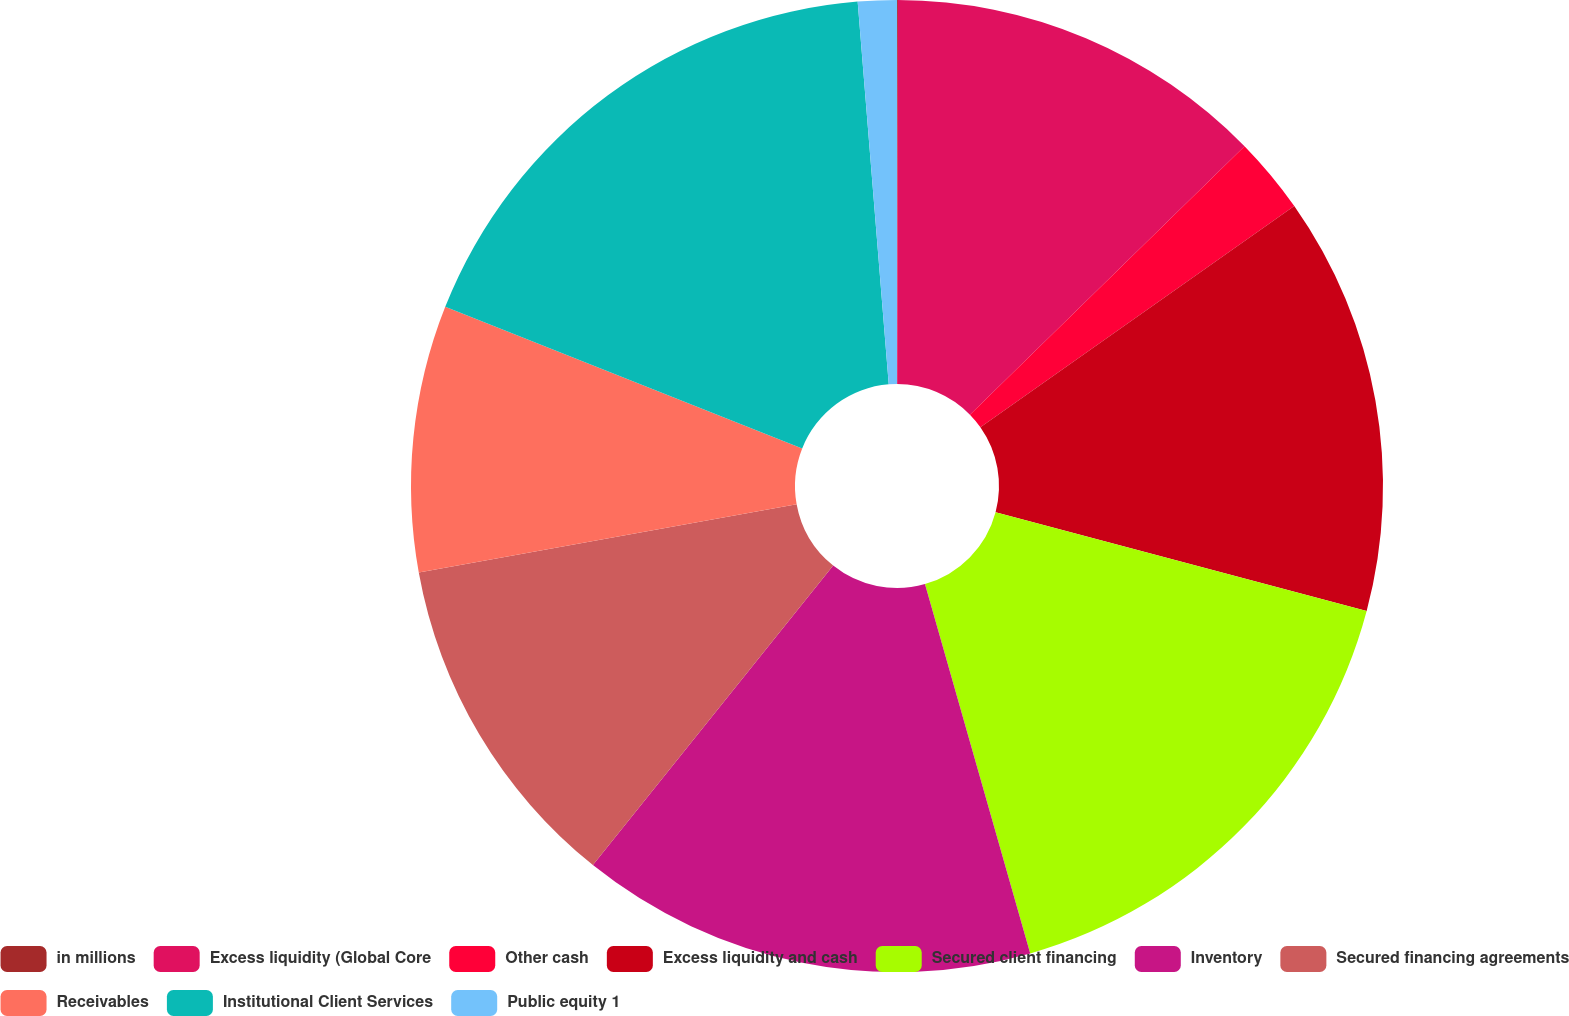Convert chart to OTSL. <chart><loc_0><loc_0><loc_500><loc_500><pie_chart><fcel>in millions<fcel>Excess liquidity (Global Core<fcel>Other cash<fcel>Excess liquidity and cash<fcel>Secured client financing<fcel>Inventory<fcel>Secured financing agreements<fcel>Receivables<fcel>Institutional Client Services<fcel>Public equity 1<nl><fcel>0.03%<fcel>12.65%<fcel>2.55%<fcel>13.91%<fcel>16.44%<fcel>15.18%<fcel>11.39%<fcel>8.86%<fcel>17.7%<fcel>1.29%<nl></chart> 